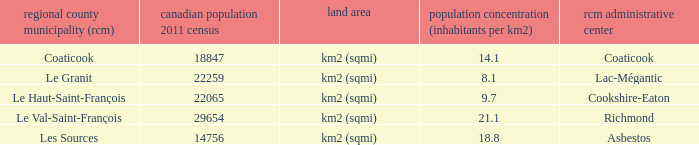What is the RCM that has a density of 9.7? Le Haut-Saint-François. 